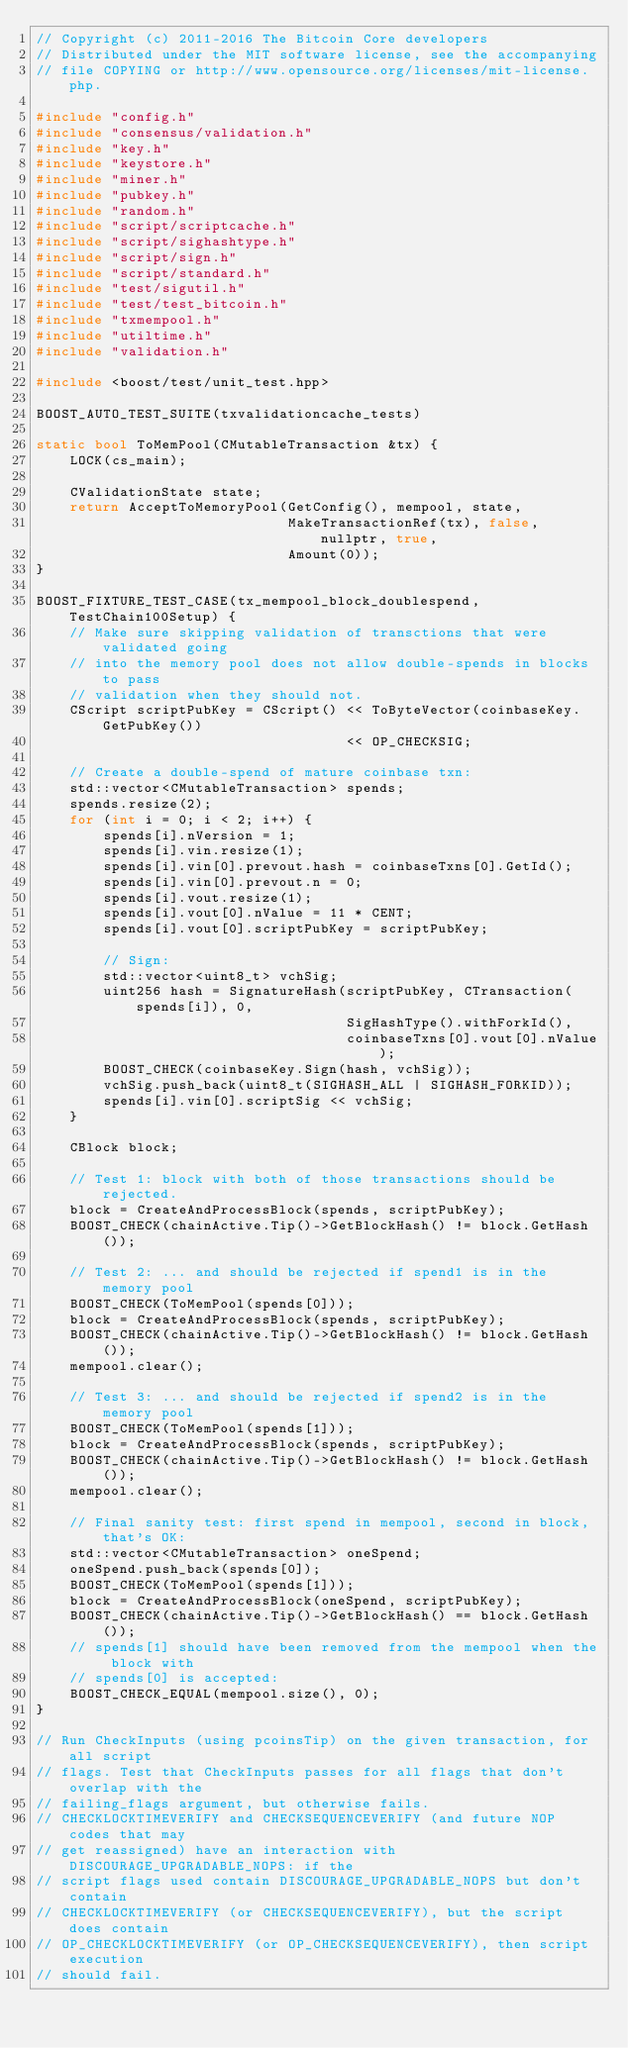<code> <loc_0><loc_0><loc_500><loc_500><_C++_>// Copyright (c) 2011-2016 The Bitcoin Core developers
// Distributed under the MIT software license, see the accompanying
// file COPYING or http://www.opensource.org/licenses/mit-license.php.

#include "config.h"
#include "consensus/validation.h"
#include "key.h"
#include "keystore.h"
#include "miner.h"
#include "pubkey.h"
#include "random.h"
#include "script/scriptcache.h"
#include "script/sighashtype.h"
#include "script/sign.h"
#include "script/standard.h"
#include "test/sigutil.h"
#include "test/test_bitcoin.h"
#include "txmempool.h"
#include "utiltime.h"
#include "validation.h"

#include <boost/test/unit_test.hpp>

BOOST_AUTO_TEST_SUITE(txvalidationcache_tests)

static bool ToMemPool(CMutableTransaction &tx) {
    LOCK(cs_main);

    CValidationState state;
    return AcceptToMemoryPool(GetConfig(), mempool, state,
                              MakeTransactionRef(tx), false, nullptr, true,
                              Amount(0));
}

BOOST_FIXTURE_TEST_CASE(tx_mempool_block_doublespend, TestChain100Setup) {
    // Make sure skipping validation of transctions that were validated going
    // into the memory pool does not allow double-spends in blocks to pass
    // validation when they should not.
    CScript scriptPubKey = CScript() << ToByteVector(coinbaseKey.GetPubKey())
                                     << OP_CHECKSIG;

    // Create a double-spend of mature coinbase txn:
    std::vector<CMutableTransaction> spends;
    spends.resize(2);
    for (int i = 0; i < 2; i++) {
        spends[i].nVersion = 1;
        spends[i].vin.resize(1);
        spends[i].vin[0].prevout.hash = coinbaseTxns[0].GetId();
        spends[i].vin[0].prevout.n = 0;
        spends[i].vout.resize(1);
        spends[i].vout[0].nValue = 11 * CENT;
        spends[i].vout[0].scriptPubKey = scriptPubKey;

        // Sign:
        std::vector<uint8_t> vchSig;
        uint256 hash = SignatureHash(scriptPubKey, CTransaction(spends[i]), 0,
                                     SigHashType().withForkId(),
                                     coinbaseTxns[0].vout[0].nValue);
        BOOST_CHECK(coinbaseKey.Sign(hash, vchSig));
        vchSig.push_back(uint8_t(SIGHASH_ALL | SIGHASH_FORKID));
        spends[i].vin[0].scriptSig << vchSig;
    }

    CBlock block;

    // Test 1: block with both of those transactions should be rejected.
    block = CreateAndProcessBlock(spends, scriptPubKey);
    BOOST_CHECK(chainActive.Tip()->GetBlockHash() != block.GetHash());

    // Test 2: ... and should be rejected if spend1 is in the memory pool
    BOOST_CHECK(ToMemPool(spends[0]));
    block = CreateAndProcessBlock(spends, scriptPubKey);
    BOOST_CHECK(chainActive.Tip()->GetBlockHash() != block.GetHash());
    mempool.clear();

    // Test 3: ... and should be rejected if spend2 is in the memory pool
    BOOST_CHECK(ToMemPool(spends[1]));
    block = CreateAndProcessBlock(spends, scriptPubKey);
    BOOST_CHECK(chainActive.Tip()->GetBlockHash() != block.GetHash());
    mempool.clear();

    // Final sanity test: first spend in mempool, second in block, that's OK:
    std::vector<CMutableTransaction> oneSpend;
    oneSpend.push_back(spends[0]);
    BOOST_CHECK(ToMemPool(spends[1]));
    block = CreateAndProcessBlock(oneSpend, scriptPubKey);
    BOOST_CHECK(chainActive.Tip()->GetBlockHash() == block.GetHash());
    // spends[1] should have been removed from the mempool when the block with
    // spends[0] is accepted:
    BOOST_CHECK_EQUAL(mempool.size(), 0);
}

// Run CheckInputs (using pcoinsTip) on the given transaction, for all script
// flags. Test that CheckInputs passes for all flags that don't overlap with the
// failing_flags argument, but otherwise fails.
// CHECKLOCKTIMEVERIFY and CHECKSEQUENCEVERIFY (and future NOP codes that may
// get reassigned) have an interaction with DISCOURAGE_UPGRADABLE_NOPS: if the
// script flags used contain DISCOURAGE_UPGRADABLE_NOPS but don't contain
// CHECKLOCKTIMEVERIFY (or CHECKSEQUENCEVERIFY), but the script does contain
// OP_CHECKLOCKTIMEVERIFY (or OP_CHECKSEQUENCEVERIFY), then script execution
// should fail.</code> 